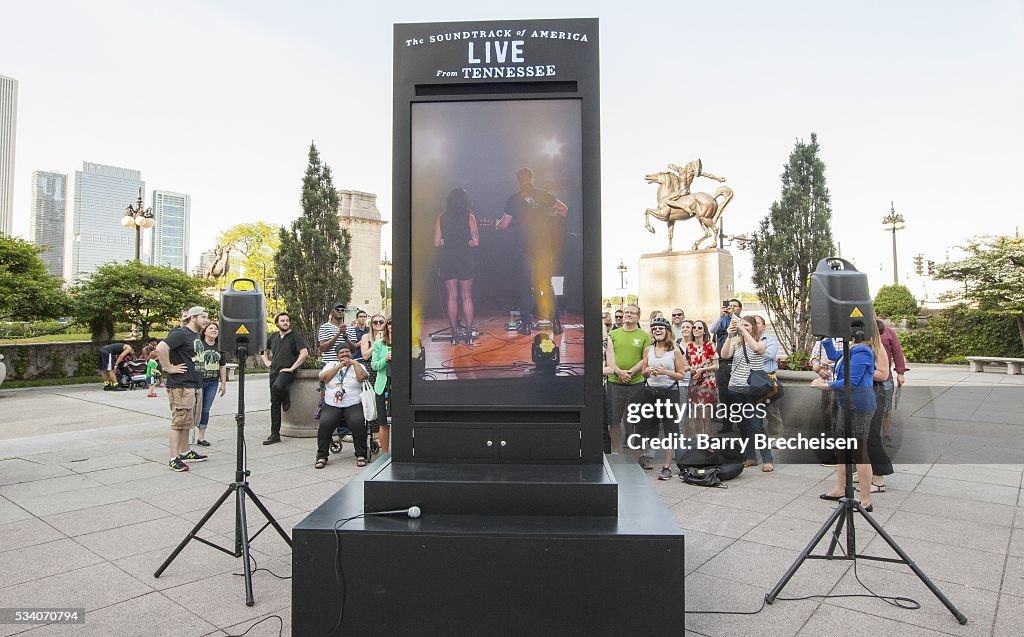What can you infer about the diversity of the audience attending this event? The audience appears to be diverse, as evidenced by the variety of attire and demeanors visible. Such events often attract a broad spectrum of people from different age groups, backgrounds, and possibly even different cultural communities. The relaxed and informal nature of the gathering, with people engaged casually, suggests that the event is welcoming and inclusive, encouraging broad participation. This diversity reflects the vibrancy and openness of the urban setting, emphasizing the community’s embrace of varied cultural expressions and public celebrations. How does the presence of greenery and the park setting enhance the experience for the attendees? The greenery and park setting immensely enhance the experience for attendees by providing a refreshing and calming environment. The lush trees and plants offer shade and a sense of tranquility amidst the urban hustle, allowing people to relax and enjoy the event in a natural setting. This blend of nature with cultural and entertainment activities fosters a more inviting and pleasant atmosphere, where individuals can connect with nature and each other, enhancing their overall experience. The park offers spaciousness, allowing for a variety of activities, and the clean, fresh air contributes to attendees' well-being, making it an ideal venue for communal gatherings. Now, let's get creative! Imagine the statue comes to life at night after the event. What might it do and why? As the night deepens and the last echoes of the event fade, the statue of the horse and rider comes to life, stepping down gracefully from its pedestal. The horse, proud and magnificent, shakes off the constriction of stillness, while the rider, a figure from the city's storied past, surveys the transformed urban landscape. Determined to explore this new era, they venture through the sleeping city, their metallic hooves resonating softly on the pavement. They might visit historical landmarks, engage with modern technologies in silent wonder, and even whisper ancient tales to those few who are awake in the witching hour, bridging the gap between the past and the present like a timeless guardian of the city’s history. 